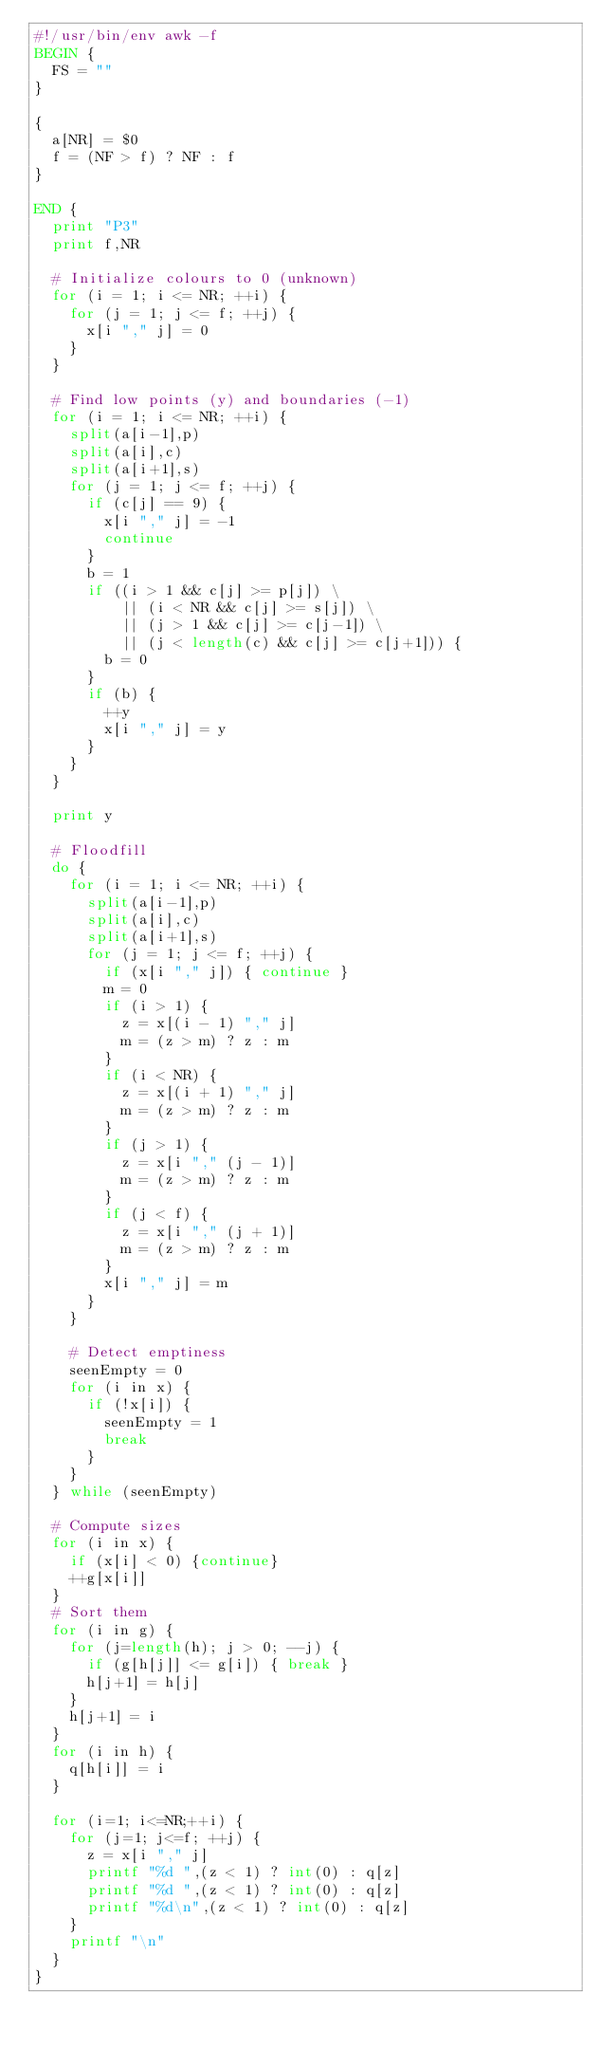<code> <loc_0><loc_0><loc_500><loc_500><_Awk_>#!/usr/bin/env awk -f
BEGIN {
	FS = ""
}

{
	a[NR] = $0
	f = (NF > f) ? NF : f
}

END {
	print "P3"
	print f,NR

	# Initialize colours to 0 (unknown)
	for (i = 1; i <= NR; ++i) {
		for (j = 1; j <= f; ++j) {
			x[i "," j] = 0
		}
	}

	# Find low points (y) and boundaries (-1)
	for (i = 1; i <= NR; ++i) {
		split(a[i-1],p)
		split(a[i],c)
		split(a[i+1],s)
		for (j = 1; j <= f; ++j) {
			if (c[j] == 9) {
				x[i "," j] = -1
				continue
			}
			b = 1
			if ((i > 1 && c[j] >= p[j]) \
			    || (i < NR && c[j] >= s[j]) \
			    || (j > 1 && c[j] >= c[j-1]) \
			    || (j < length(c) && c[j] >= c[j+1])) {
				b = 0
			}
			if (b) {
				++y
				x[i "," j] = y
			}
		}
	}

	print y

	# Floodfill
	do {
		for (i = 1; i <= NR; ++i) {
			split(a[i-1],p)
			split(a[i],c)
			split(a[i+1],s)
			for (j = 1; j <= f; ++j) {
				if (x[i "," j]) { continue }
				m = 0
				if (i > 1) {
					z = x[(i - 1) "," j]
					m = (z > m) ? z : m
				}
				if (i < NR) {
					z = x[(i + 1) "," j]
					m = (z > m) ? z : m
				}
				if (j > 1) {
					z = x[i "," (j - 1)]
					m = (z > m) ? z : m
				}
				if (j < f) {
					z = x[i "," (j + 1)]
					m = (z > m) ? z : m
				}
				x[i "," j] = m
			}
		}

		# Detect emptiness
		seenEmpty = 0
		for (i in x) {
			if (!x[i]) {
				seenEmpty = 1
				break
			}
		}
	} while (seenEmpty)

	# Compute sizes
	for (i in x) {
		if (x[i] < 0) {continue}
		++g[x[i]]
	}
	# Sort them
	for (i in g) {
		for (j=length(h); j > 0; --j) {
			if (g[h[j]] <= g[i]) { break }
			h[j+1] = h[j]
		}
		h[j+1] = i
	}
	for (i in h) {
		q[h[i]] = i
	}

	for (i=1; i<=NR;++i) {
		for (j=1; j<=f; ++j) {
			z = x[i "," j]
			printf "%d ",(z < 1) ? int(0) : q[z]
			printf "%d ",(z < 1) ? int(0) : q[z]
			printf "%d\n",(z < 1) ? int(0) : q[z]
		}
		printf "\n"
	}
}
</code> 